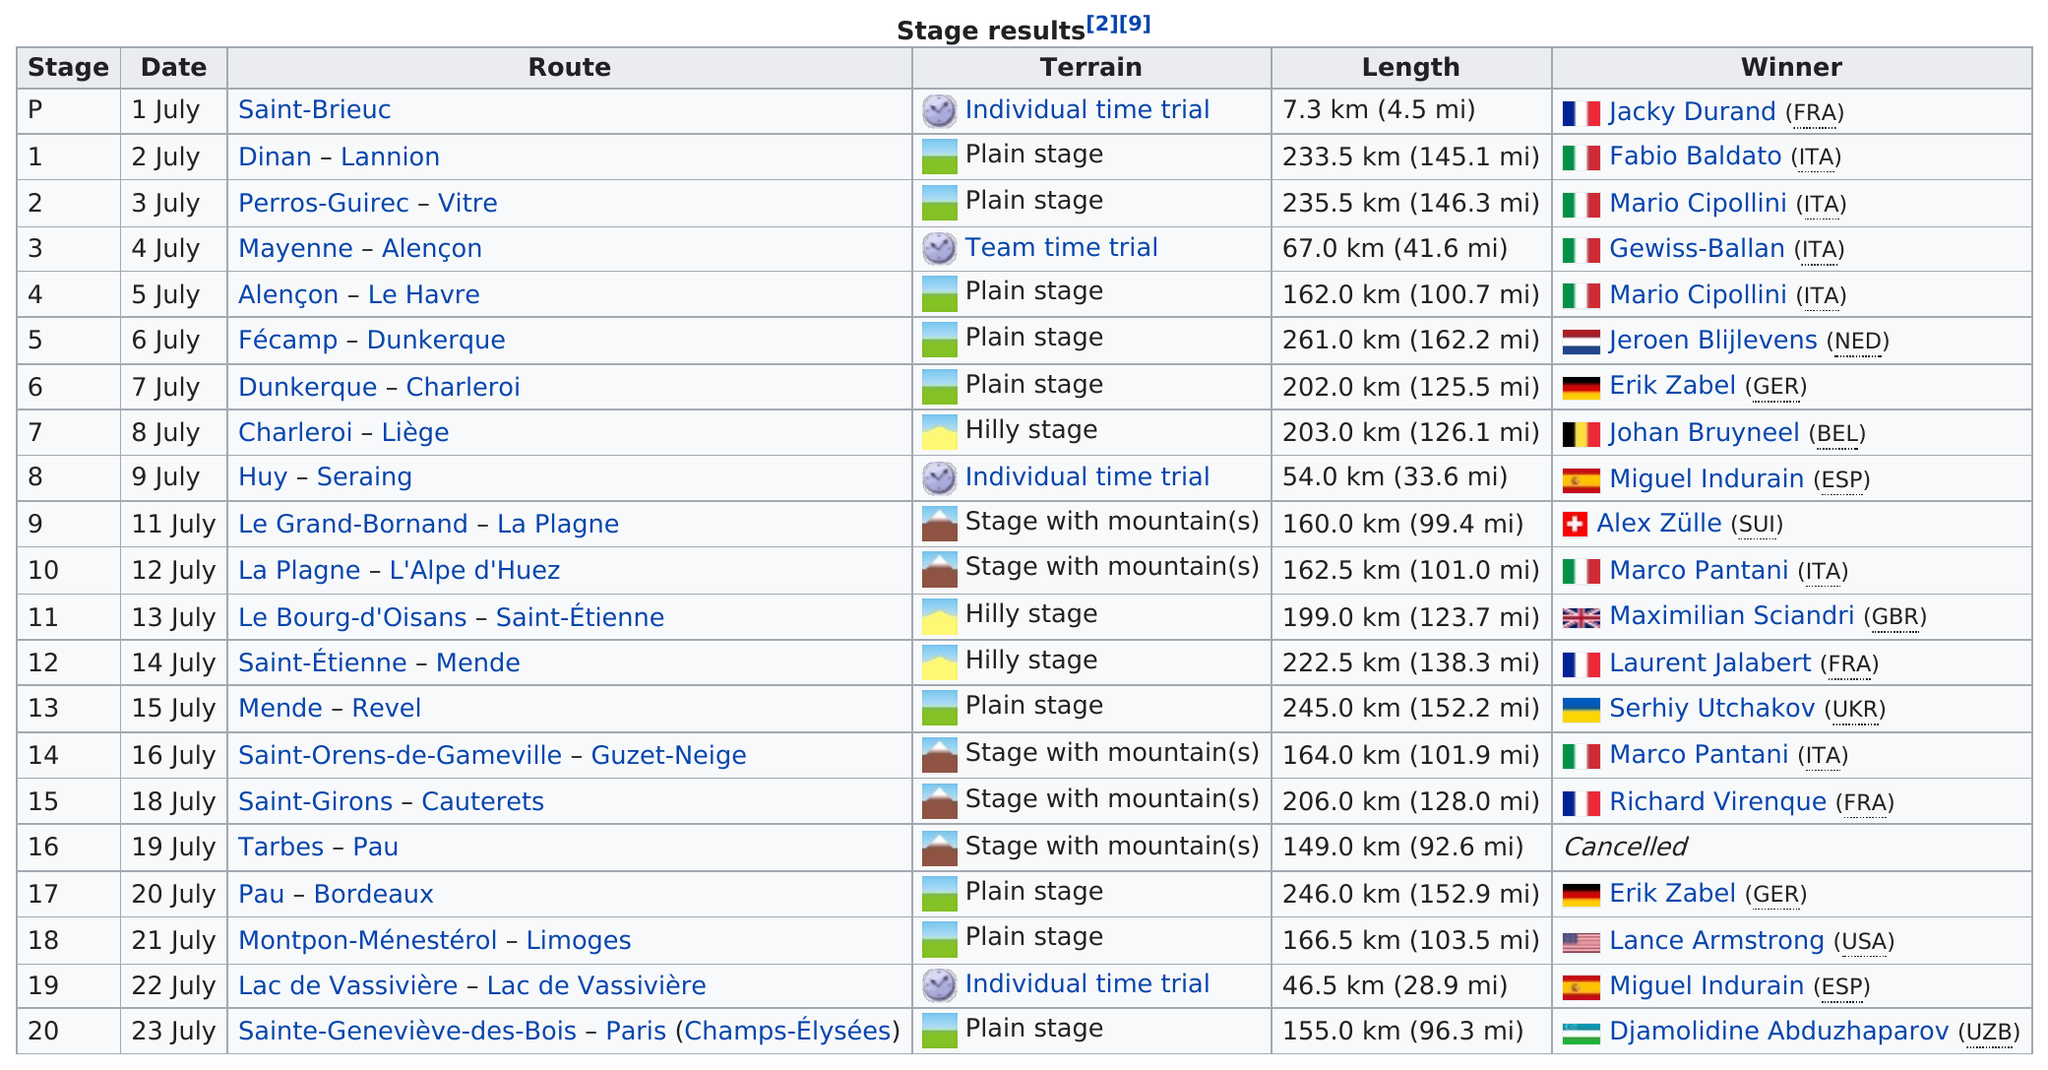Mention a couple of crucial points in this snapshot. Italy had the most stage-winners among all countries. On July 8th, a total of 203.0 km (126.1 mi) were raced consecutively. Out of all the routes, there are four that have a total distance of less than 100 kilometers. The total number of winners from Italy was 6. The most common type of terrain was a plain stage. 